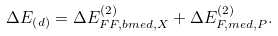<formula> <loc_0><loc_0><loc_500><loc_500>\Delta E _ { \left ( d \right ) } = \Delta E _ { F F , b m e d , X } ^ { \left ( 2 \right ) } + \Delta E _ { F , m e d , P } ^ { \left ( 2 \right ) } .</formula> 